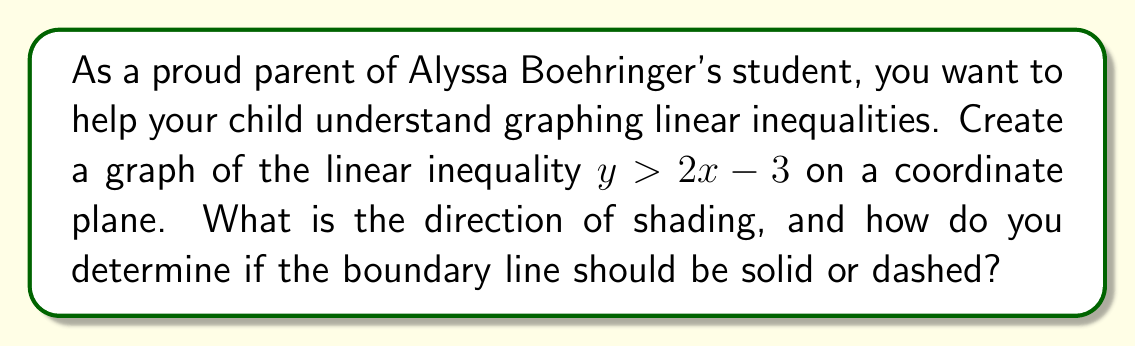Provide a solution to this math problem. To graph the linear inequality $y > 2x - 3$, follow these steps:

1. First, treat the inequality as an equation and graph the line $y = 2x - 3$:
   a. The slope is 2, so the line rises 2 units for every 1 unit to the right.
   b. The y-intercept is -3, so the line crosses the y-axis at (0, -3).
   c. Plot a few points, such as (0, -3) and (3, 3), and draw the line through them.

2. Determine if the line should be solid or dashed:
   - For $>$ or $<$, use a dashed line.
   - For $\geq$ or $\leq$, use a solid line.
   In this case, we have $>$, so we use a dashed line.

3. To determine the direction of shading:
   a. Choose a test point not on the line, such as (0, 0).
   b. Substitute the coordinates into the inequality:
      $0 \stackrel{?}{>} 2(0) - 3$
      $0 > -3$
   c. Since this is true, the point (0, 0) satisfies the inequality.
   d. Shade the side of the line that includes this point.

4. The shading should be above the line because the test point (0, 0) is above the line and satisfies the inequality.

[asy]
import graph;
size(200);
xaxis("x", -5, 5, arrow=Arrow);
yaxis("y", -5, 5, arrow=Arrow);

real f(real x) {return 2x - 3;}
draw(graph(f, -5, 5), dashed);

fill((5,10)--(5,f(5))--(-5,f(-5))--(-5,10)--cycle, lightgray);

label("$y > 2x - 3$", (3,4), NE);
[/asy]
Answer: The graph of $y > 2x - 3$ has a dashed boundary line and is shaded above the line. 